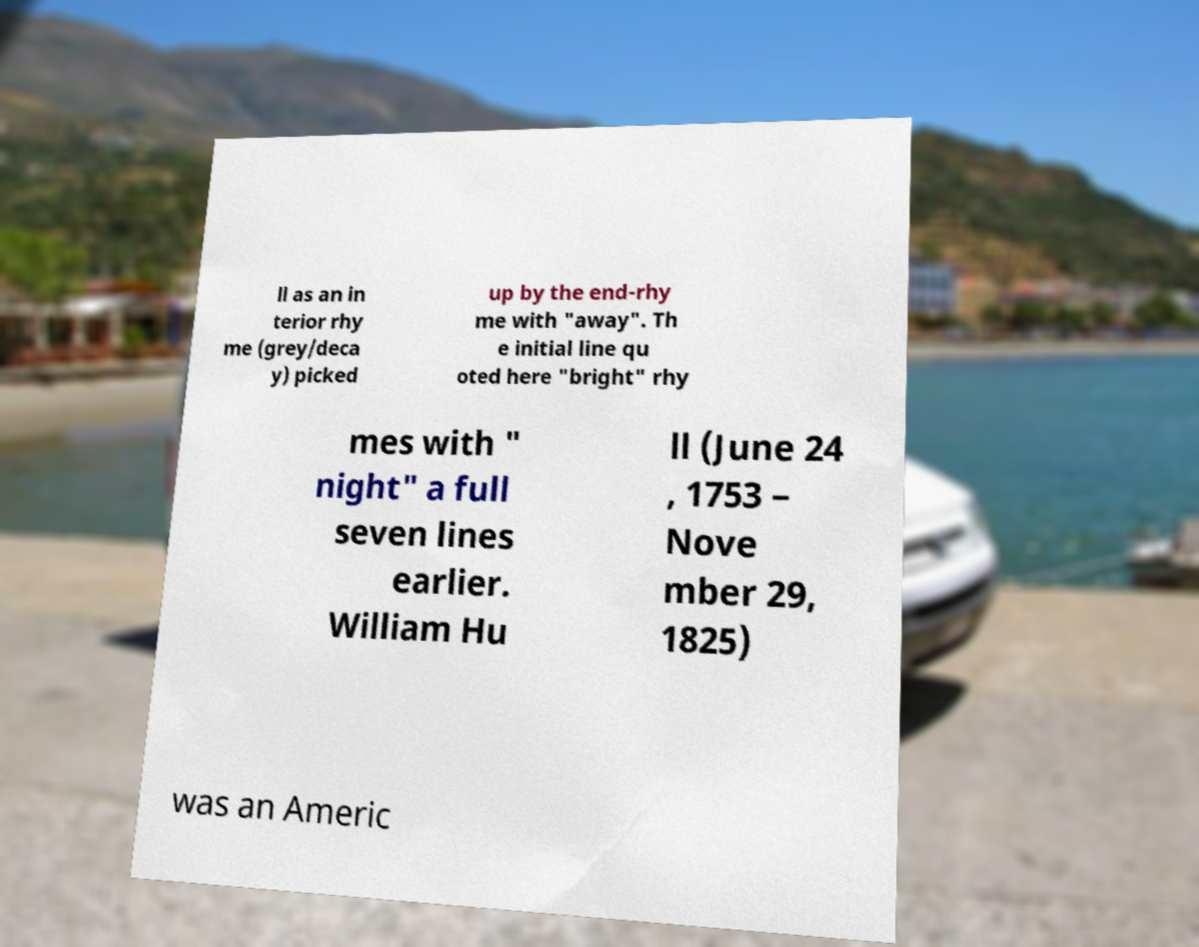Please identify and transcribe the text found in this image. ll as an in terior rhy me (grey/deca y) picked up by the end-rhy me with "away". Th e initial line qu oted here "bright" rhy mes with " night" a full seven lines earlier. William Hu ll (June 24 , 1753 – Nove mber 29, 1825) was an Americ 